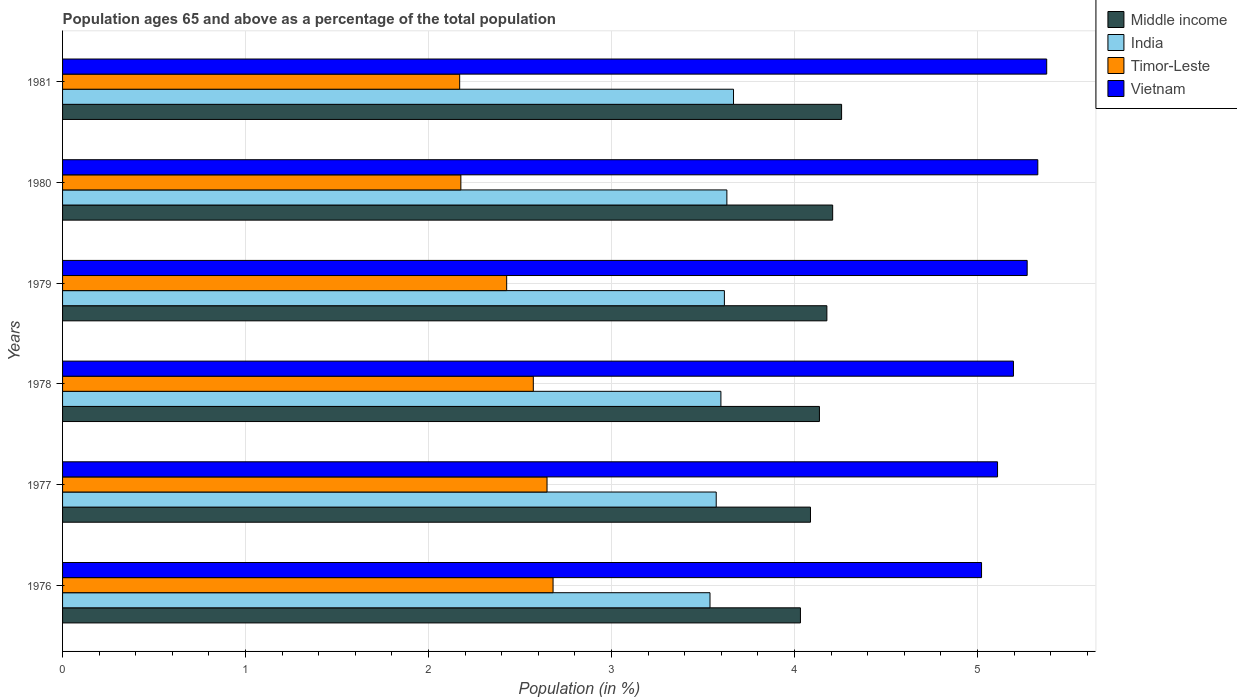How many different coloured bars are there?
Offer a terse response. 4. How many groups of bars are there?
Keep it short and to the point. 6. Are the number of bars per tick equal to the number of legend labels?
Ensure brevity in your answer.  Yes. How many bars are there on the 2nd tick from the top?
Make the answer very short. 4. What is the label of the 6th group of bars from the top?
Keep it short and to the point. 1976. In how many cases, is the number of bars for a given year not equal to the number of legend labels?
Make the answer very short. 0. What is the percentage of the population ages 65 and above in Vietnam in 1978?
Your response must be concise. 5.2. Across all years, what is the maximum percentage of the population ages 65 and above in India?
Make the answer very short. 3.67. Across all years, what is the minimum percentage of the population ages 65 and above in Vietnam?
Ensure brevity in your answer.  5.02. In which year was the percentage of the population ages 65 and above in Timor-Leste maximum?
Keep it short and to the point. 1976. In which year was the percentage of the population ages 65 and above in Middle income minimum?
Your response must be concise. 1976. What is the total percentage of the population ages 65 and above in Timor-Leste in the graph?
Give a very brief answer. 14.68. What is the difference between the percentage of the population ages 65 and above in India in 1976 and that in 1978?
Offer a very short reply. -0.06. What is the difference between the percentage of the population ages 65 and above in India in 1981 and the percentage of the population ages 65 and above in Timor-Leste in 1978?
Make the answer very short. 1.09. What is the average percentage of the population ages 65 and above in Vietnam per year?
Provide a short and direct response. 5.22. In the year 1981, what is the difference between the percentage of the population ages 65 and above in Timor-Leste and percentage of the population ages 65 and above in Vietnam?
Keep it short and to the point. -3.21. In how many years, is the percentage of the population ages 65 and above in India greater than 4.2 ?
Make the answer very short. 0. What is the ratio of the percentage of the population ages 65 and above in India in 1979 to that in 1981?
Provide a succinct answer. 0.99. What is the difference between the highest and the second highest percentage of the population ages 65 and above in India?
Make the answer very short. 0.04. What is the difference between the highest and the lowest percentage of the population ages 65 and above in India?
Offer a very short reply. 0.13. In how many years, is the percentage of the population ages 65 and above in India greater than the average percentage of the population ages 65 and above in India taken over all years?
Your answer should be very brief. 3. Is it the case that in every year, the sum of the percentage of the population ages 65 and above in Middle income and percentage of the population ages 65 and above in India is greater than the sum of percentage of the population ages 65 and above in Timor-Leste and percentage of the population ages 65 and above in Vietnam?
Give a very brief answer. No. What does the 2nd bar from the top in 1980 represents?
Provide a short and direct response. Timor-Leste. What does the 4th bar from the bottom in 1976 represents?
Give a very brief answer. Vietnam. How many bars are there?
Provide a succinct answer. 24. Are all the bars in the graph horizontal?
Keep it short and to the point. Yes. How many years are there in the graph?
Give a very brief answer. 6. Does the graph contain any zero values?
Make the answer very short. No. Where does the legend appear in the graph?
Offer a terse response. Top right. How many legend labels are there?
Provide a short and direct response. 4. How are the legend labels stacked?
Your response must be concise. Vertical. What is the title of the graph?
Your response must be concise. Population ages 65 and above as a percentage of the total population. What is the Population (in %) of Middle income in 1976?
Provide a succinct answer. 4.03. What is the Population (in %) of India in 1976?
Offer a terse response. 3.54. What is the Population (in %) in Timor-Leste in 1976?
Your response must be concise. 2.68. What is the Population (in %) of Vietnam in 1976?
Offer a very short reply. 5.02. What is the Population (in %) in Middle income in 1977?
Provide a succinct answer. 4.09. What is the Population (in %) in India in 1977?
Offer a very short reply. 3.57. What is the Population (in %) of Timor-Leste in 1977?
Keep it short and to the point. 2.65. What is the Population (in %) of Vietnam in 1977?
Provide a succinct answer. 5.11. What is the Population (in %) of Middle income in 1978?
Offer a very short reply. 4.14. What is the Population (in %) in India in 1978?
Provide a short and direct response. 3.6. What is the Population (in %) in Timor-Leste in 1978?
Give a very brief answer. 2.57. What is the Population (in %) in Vietnam in 1978?
Ensure brevity in your answer.  5.2. What is the Population (in %) in Middle income in 1979?
Offer a very short reply. 4.18. What is the Population (in %) of India in 1979?
Offer a very short reply. 3.62. What is the Population (in %) of Timor-Leste in 1979?
Ensure brevity in your answer.  2.43. What is the Population (in %) of Vietnam in 1979?
Make the answer very short. 5.27. What is the Population (in %) of Middle income in 1980?
Give a very brief answer. 4.21. What is the Population (in %) in India in 1980?
Your response must be concise. 3.63. What is the Population (in %) in Timor-Leste in 1980?
Keep it short and to the point. 2.18. What is the Population (in %) in Vietnam in 1980?
Provide a succinct answer. 5.33. What is the Population (in %) of Middle income in 1981?
Your response must be concise. 4.26. What is the Population (in %) of India in 1981?
Provide a short and direct response. 3.67. What is the Population (in %) in Timor-Leste in 1981?
Ensure brevity in your answer.  2.17. What is the Population (in %) of Vietnam in 1981?
Provide a short and direct response. 5.38. Across all years, what is the maximum Population (in %) in Middle income?
Your answer should be very brief. 4.26. Across all years, what is the maximum Population (in %) in India?
Ensure brevity in your answer.  3.67. Across all years, what is the maximum Population (in %) of Timor-Leste?
Ensure brevity in your answer.  2.68. Across all years, what is the maximum Population (in %) of Vietnam?
Offer a very short reply. 5.38. Across all years, what is the minimum Population (in %) of Middle income?
Offer a terse response. 4.03. Across all years, what is the minimum Population (in %) in India?
Provide a succinct answer. 3.54. Across all years, what is the minimum Population (in %) in Timor-Leste?
Provide a succinct answer. 2.17. Across all years, what is the minimum Population (in %) in Vietnam?
Provide a succinct answer. 5.02. What is the total Population (in %) in Middle income in the graph?
Keep it short and to the point. 24.9. What is the total Population (in %) of India in the graph?
Offer a very short reply. 21.62. What is the total Population (in %) of Timor-Leste in the graph?
Offer a terse response. 14.68. What is the total Population (in %) in Vietnam in the graph?
Offer a terse response. 31.31. What is the difference between the Population (in %) of Middle income in 1976 and that in 1977?
Your answer should be very brief. -0.05. What is the difference between the Population (in %) of India in 1976 and that in 1977?
Offer a terse response. -0.03. What is the difference between the Population (in %) of Timor-Leste in 1976 and that in 1977?
Ensure brevity in your answer.  0.03. What is the difference between the Population (in %) of Vietnam in 1976 and that in 1977?
Your answer should be very brief. -0.09. What is the difference between the Population (in %) of Middle income in 1976 and that in 1978?
Offer a terse response. -0.1. What is the difference between the Population (in %) in India in 1976 and that in 1978?
Offer a very short reply. -0.06. What is the difference between the Population (in %) in Timor-Leste in 1976 and that in 1978?
Provide a succinct answer. 0.11. What is the difference between the Population (in %) of Vietnam in 1976 and that in 1978?
Make the answer very short. -0.17. What is the difference between the Population (in %) of Middle income in 1976 and that in 1979?
Your answer should be very brief. -0.14. What is the difference between the Population (in %) in India in 1976 and that in 1979?
Your answer should be compact. -0.08. What is the difference between the Population (in %) of Timor-Leste in 1976 and that in 1979?
Your answer should be very brief. 0.25. What is the difference between the Population (in %) of Vietnam in 1976 and that in 1979?
Keep it short and to the point. -0.25. What is the difference between the Population (in %) of Middle income in 1976 and that in 1980?
Give a very brief answer. -0.18. What is the difference between the Population (in %) of India in 1976 and that in 1980?
Your response must be concise. -0.09. What is the difference between the Population (in %) of Timor-Leste in 1976 and that in 1980?
Your answer should be very brief. 0.5. What is the difference between the Population (in %) of Vietnam in 1976 and that in 1980?
Provide a succinct answer. -0.31. What is the difference between the Population (in %) of Middle income in 1976 and that in 1981?
Make the answer very short. -0.22. What is the difference between the Population (in %) in India in 1976 and that in 1981?
Give a very brief answer. -0.13. What is the difference between the Population (in %) in Timor-Leste in 1976 and that in 1981?
Offer a terse response. 0.51. What is the difference between the Population (in %) of Vietnam in 1976 and that in 1981?
Your answer should be compact. -0.36. What is the difference between the Population (in %) of Middle income in 1977 and that in 1978?
Provide a short and direct response. -0.05. What is the difference between the Population (in %) of India in 1977 and that in 1978?
Ensure brevity in your answer.  -0.03. What is the difference between the Population (in %) in Timor-Leste in 1977 and that in 1978?
Give a very brief answer. 0.07. What is the difference between the Population (in %) in Vietnam in 1977 and that in 1978?
Provide a succinct answer. -0.09. What is the difference between the Population (in %) of Middle income in 1977 and that in 1979?
Your answer should be compact. -0.09. What is the difference between the Population (in %) in India in 1977 and that in 1979?
Keep it short and to the point. -0.04. What is the difference between the Population (in %) of Timor-Leste in 1977 and that in 1979?
Make the answer very short. 0.22. What is the difference between the Population (in %) in Vietnam in 1977 and that in 1979?
Ensure brevity in your answer.  -0.16. What is the difference between the Population (in %) of Middle income in 1977 and that in 1980?
Give a very brief answer. -0.12. What is the difference between the Population (in %) of India in 1977 and that in 1980?
Offer a terse response. -0.06. What is the difference between the Population (in %) of Timor-Leste in 1977 and that in 1980?
Provide a short and direct response. 0.47. What is the difference between the Population (in %) of Vietnam in 1977 and that in 1980?
Give a very brief answer. -0.22. What is the difference between the Population (in %) of Middle income in 1977 and that in 1981?
Your response must be concise. -0.17. What is the difference between the Population (in %) of India in 1977 and that in 1981?
Keep it short and to the point. -0.09. What is the difference between the Population (in %) of Timor-Leste in 1977 and that in 1981?
Provide a succinct answer. 0.48. What is the difference between the Population (in %) in Vietnam in 1977 and that in 1981?
Keep it short and to the point. -0.27. What is the difference between the Population (in %) in Middle income in 1978 and that in 1979?
Keep it short and to the point. -0.04. What is the difference between the Population (in %) of India in 1978 and that in 1979?
Offer a terse response. -0.02. What is the difference between the Population (in %) in Timor-Leste in 1978 and that in 1979?
Make the answer very short. 0.15. What is the difference between the Population (in %) in Vietnam in 1978 and that in 1979?
Your response must be concise. -0.07. What is the difference between the Population (in %) of Middle income in 1978 and that in 1980?
Provide a succinct answer. -0.07. What is the difference between the Population (in %) in India in 1978 and that in 1980?
Give a very brief answer. -0.03. What is the difference between the Population (in %) of Timor-Leste in 1978 and that in 1980?
Ensure brevity in your answer.  0.4. What is the difference between the Population (in %) of Vietnam in 1978 and that in 1980?
Offer a very short reply. -0.13. What is the difference between the Population (in %) in Middle income in 1978 and that in 1981?
Your answer should be compact. -0.12. What is the difference between the Population (in %) of India in 1978 and that in 1981?
Your answer should be compact. -0.07. What is the difference between the Population (in %) in Timor-Leste in 1978 and that in 1981?
Your answer should be compact. 0.4. What is the difference between the Population (in %) of Vietnam in 1978 and that in 1981?
Your answer should be very brief. -0.18. What is the difference between the Population (in %) in Middle income in 1979 and that in 1980?
Provide a short and direct response. -0.03. What is the difference between the Population (in %) in India in 1979 and that in 1980?
Your response must be concise. -0.01. What is the difference between the Population (in %) in Timor-Leste in 1979 and that in 1980?
Keep it short and to the point. 0.25. What is the difference between the Population (in %) of Vietnam in 1979 and that in 1980?
Make the answer very short. -0.06. What is the difference between the Population (in %) of Middle income in 1979 and that in 1981?
Give a very brief answer. -0.08. What is the difference between the Population (in %) in India in 1979 and that in 1981?
Your response must be concise. -0.05. What is the difference between the Population (in %) in Timor-Leste in 1979 and that in 1981?
Give a very brief answer. 0.26. What is the difference between the Population (in %) in Vietnam in 1979 and that in 1981?
Your response must be concise. -0.11. What is the difference between the Population (in %) of Middle income in 1980 and that in 1981?
Provide a short and direct response. -0.05. What is the difference between the Population (in %) in India in 1980 and that in 1981?
Make the answer very short. -0.04. What is the difference between the Population (in %) in Timor-Leste in 1980 and that in 1981?
Provide a succinct answer. 0.01. What is the difference between the Population (in %) of Vietnam in 1980 and that in 1981?
Offer a terse response. -0.05. What is the difference between the Population (in %) of Middle income in 1976 and the Population (in %) of India in 1977?
Offer a very short reply. 0.46. What is the difference between the Population (in %) of Middle income in 1976 and the Population (in %) of Timor-Leste in 1977?
Provide a short and direct response. 1.39. What is the difference between the Population (in %) of Middle income in 1976 and the Population (in %) of Vietnam in 1977?
Give a very brief answer. -1.08. What is the difference between the Population (in %) of India in 1976 and the Population (in %) of Timor-Leste in 1977?
Your response must be concise. 0.89. What is the difference between the Population (in %) of India in 1976 and the Population (in %) of Vietnam in 1977?
Your answer should be very brief. -1.57. What is the difference between the Population (in %) in Timor-Leste in 1976 and the Population (in %) in Vietnam in 1977?
Ensure brevity in your answer.  -2.43. What is the difference between the Population (in %) of Middle income in 1976 and the Population (in %) of India in 1978?
Offer a very short reply. 0.43. What is the difference between the Population (in %) in Middle income in 1976 and the Population (in %) in Timor-Leste in 1978?
Your response must be concise. 1.46. What is the difference between the Population (in %) in Middle income in 1976 and the Population (in %) in Vietnam in 1978?
Your answer should be very brief. -1.16. What is the difference between the Population (in %) in India in 1976 and the Population (in %) in Timor-Leste in 1978?
Your answer should be compact. 0.97. What is the difference between the Population (in %) in India in 1976 and the Population (in %) in Vietnam in 1978?
Offer a very short reply. -1.66. What is the difference between the Population (in %) in Timor-Leste in 1976 and the Population (in %) in Vietnam in 1978?
Ensure brevity in your answer.  -2.52. What is the difference between the Population (in %) of Middle income in 1976 and the Population (in %) of India in 1979?
Your answer should be compact. 0.42. What is the difference between the Population (in %) of Middle income in 1976 and the Population (in %) of Timor-Leste in 1979?
Provide a short and direct response. 1.61. What is the difference between the Population (in %) in Middle income in 1976 and the Population (in %) in Vietnam in 1979?
Provide a succinct answer. -1.24. What is the difference between the Population (in %) of India in 1976 and the Population (in %) of Timor-Leste in 1979?
Offer a terse response. 1.11. What is the difference between the Population (in %) of India in 1976 and the Population (in %) of Vietnam in 1979?
Keep it short and to the point. -1.73. What is the difference between the Population (in %) of Timor-Leste in 1976 and the Population (in %) of Vietnam in 1979?
Your answer should be very brief. -2.59. What is the difference between the Population (in %) of Middle income in 1976 and the Population (in %) of India in 1980?
Ensure brevity in your answer.  0.4. What is the difference between the Population (in %) in Middle income in 1976 and the Population (in %) in Timor-Leste in 1980?
Offer a terse response. 1.86. What is the difference between the Population (in %) in Middle income in 1976 and the Population (in %) in Vietnam in 1980?
Your response must be concise. -1.3. What is the difference between the Population (in %) of India in 1976 and the Population (in %) of Timor-Leste in 1980?
Offer a terse response. 1.36. What is the difference between the Population (in %) in India in 1976 and the Population (in %) in Vietnam in 1980?
Offer a very short reply. -1.79. What is the difference between the Population (in %) of Timor-Leste in 1976 and the Population (in %) of Vietnam in 1980?
Your answer should be compact. -2.65. What is the difference between the Population (in %) in Middle income in 1976 and the Population (in %) in India in 1981?
Ensure brevity in your answer.  0.37. What is the difference between the Population (in %) of Middle income in 1976 and the Population (in %) of Timor-Leste in 1981?
Provide a succinct answer. 1.86. What is the difference between the Population (in %) of Middle income in 1976 and the Population (in %) of Vietnam in 1981?
Offer a terse response. -1.35. What is the difference between the Population (in %) in India in 1976 and the Population (in %) in Timor-Leste in 1981?
Make the answer very short. 1.37. What is the difference between the Population (in %) in India in 1976 and the Population (in %) in Vietnam in 1981?
Make the answer very short. -1.84. What is the difference between the Population (in %) of Timor-Leste in 1976 and the Population (in %) of Vietnam in 1981?
Provide a succinct answer. -2.7. What is the difference between the Population (in %) of Middle income in 1977 and the Population (in %) of India in 1978?
Ensure brevity in your answer.  0.49. What is the difference between the Population (in %) of Middle income in 1977 and the Population (in %) of Timor-Leste in 1978?
Ensure brevity in your answer.  1.51. What is the difference between the Population (in %) of Middle income in 1977 and the Population (in %) of Vietnam in 1978?
Give a very brief answer. -1.11. What is the difference between the Population (in %) of India in 1977 and the Population (in %) of Timor-Leste in 1978?
Make the answer very short. 1. What is the difference between the Population (in %) of India in 1977 and the Population (in %) of Vietnam in 1978?
Your response must be concise. -1.62. What is the difference between the Population (in %) of Timor-Leste in 1977 and the Population (in %) of Vietnam in 1978?
Your answer should be very brief. -2.55. What is the difference between the Population (in %) in Middle income in 1977 and the Population (in %) in India in 1979?
Offer a very short reply. 0.47. What is the difference between the Population (in %) of Middle income in 1977 and the Population (in %) of Timor-Leste in 1979?
Offer a terse response. 1.66. What is the difference between the Population (in %) of Middle income in 1977 and the Population (in %) of Vietnam in 1979?
Your response must be concise. -1.18. What is the difference between the Population (in %) in India in 1977 and the Population (in %) in Timor-Leste in 1979?
Keep it short and to the point. 1.15. What is the difference between the Population (in %) of India in 1977 and the Population (in %) of Vietnam in 1979?
Ensure brevity in your answer.  -1.7. What is the difference between the Population (in %) of Timor-Leste in 1977 and the Population (in %) of Vietnam in 1979?
Give a very brief answer. -2.62. What is the difference between the Population (in %) of Middle income in 1977 and the Population (in %) of India in 1980?
Your response must be concise. 0.46. What is the difference between the Population (in %) of Middle income in 1977 and the Population (in %) of Timor-Leste in 1980?
Your answer should be compact. 1.91. What is the difference between the Population (in %) in Middle income in 1977 and the Population (in %) in Vietnam in 1980?
Provide a succinct answer. -1.24. What is the difference between the Population (in %) in India in 1977 and the Population (in %) in Timor-Leste in 1980?
Provide a succinct answer. 1.4. What is the difference between the Population (in %) of India in 1977 and the Population (in %) of Vietnam in 1980?
Provide a succinct answer. -1.76. What is the difference between the Population (in %) in Timor-Leste in 1977 and the Population (in %) in Vietnam in 1980?
Your answer should be compact. -2.68. What is the difference between the Population (in %) in Middle income in 1977 and the Population (in %) in India in 1981?
Your answer should be compact. 0.42. What is the difference between the Population (in %) in Middle income in 1977 and the Population (in %) in Timor-Leste in 1981?
Offer a very short reply. 1.92. What is the difference between the Population (in %) of Middle income in 1977 and the Population (in %) of Vietnam in 1981?
Your answer should be very brief. -1.29. What is the difference between the Population (in %) in India in 1977 and the Population (in %) in Timor-Leste in 1981?
Your answer should be compact. 1.4. What is the difference between the Population (in %) in India in 1977 and the Population (in %) in Vietnam in 1981?
Give a very brief answer. -1.81. What is the difference between the Population (in %) of Timor-Leste in 1977 and the Population (in %) of Vietnam in 1981?
Keep it short and to the point. -2.73. What is the difference between the Population (in %) of Middle income in 1978 and the Population (in %) of India in 1979?
Keep it short and to the point. 0.52. What is the difference between the Population (in %) in Middle income in 1978 and the Population (in %) in Timor-Leste in 1979?
Offer a very short reply. 1.71. What is the difference between the Population (in %) in Middle income in 1978 and the Population (in %) in Vietnam in 1979?
Keep it short and to the point. -1.14. What is the difference between the Population (in %) of India in 1978 and the Population (in %) of Timor-Leste in 1979?
Offer a very short reply. 1.17. What is the difference between the Population (in %) of India in 1978 and the Population (in %) of Vietnam in 1979?
Your answer should be very brief. -1.67. What is the difference between the Population (in %) in Timor-Leste in 1978 and the Population (in %) in Vietnam in 1979?
Your answer should be very brief. -2.7. What is the difference between the Population (in %) in Middle income in 1978 and the Population (in %) in India in 1980?
Provide a succinct answer. 0.51. What is the difference between the Population (in %) of Middle income in 1978 and the Population (in %) of Timor-Leste in 1980?
Make the answer very short. 1.96. What is the difference between the Population (in %) of Middle income in 1978 and the Population (in %) of Vietnam in 1980?
Provide a short and direct response. -1.19. What is the difference between the Population (in %) in India in 1978 and the Population (in %) in Timor-Leste in 1980?
Give a very brief answer. 1.42. What is the difference between the Population (in %) of India in 1978 and the Population (in %) of Vietnam in 1980?
Give a very brief answer. -1.73. What is the difference between the Population (in %) in Timor-Leste in 1978 and the Population (in %) in Vietnam in 1980?
Your response must be concise. -2.76. What is the difference between the Population (in %) of Middle income in 1978 and the Population (in %) of India in 1981?
Ensure brevity in your answer.  0.47. What is the difference between the Population (in %) of Middle income in 1978 and the Population (in %) of Timor-Leste in 1981?
Keep it short and to the point. 1.97. What is the difference between the Population (in %) of Middle income in 1978 and the Population (in %) of Vietnam in 1981?
Your response must be concise. -1.24. What is the difference between the Population (in %) in India in 1978 and the Population (in %) in Timor-Leste in 1981?
Ensure brevity in your answer.  1.43. What is the difference between the Population (in %) in India in 1978 and the Population (in %) in Vietnam in 1981?
Offer a terse response. -1.78. What is the difference between the Population (in %) of Timor-Leste in 1978 and the Population (in %) of Vietnam in 1981?
Your answer should be very brief. -2.81. What is the difference between the Population (in %) of Middle income in 1979 and the Population (in %) of India in 1980?
Keep it short and to the point. 0.55. What is the difference between the Population (in %) in Middle income in 1979 and the Population (in %) in Timor-Leste in 1980?
Your response must be concise. 2. What is the difference between the Population (in %) in Middle income in 1979 and the Population (in %) in Vietnam in 1980?
Ensure brevity in your answer.  -1.15. What is the difference between the Population (in %) of India in 1979 and the Population (in %) of Timor-Leste in 1980?
Give a very brief answer. 1.44. What is the difference between the Population (in %) in India in 1979 and the Population (in %) in Vietnam in 1980?
Offer a terse response. -1.71. What is the difference between the Population (in %) of Timor-Leste in 1979 and the Population (in %) of Vietnam in 1980?
Ensure brevity in your answer.  -2.9. What is the difference between the Population (in %) of Middle income in 1979 and the Population (in %) of India in 1981?
Give a very brief answer. 0.51. What is the difference between the Population (in %) of Middle income in 1979 and the Population (in %) of Timor-Leste in 1981?
Provide a short and direct response. 2.01. What is the difference between the Population (in %) in Middle income in 1979 and the Population (in %) in Vietnam in 1981?
Keep it short and to the point. -1.2. What is the difference between the Population (in %) of India in 1979 and the Population (in %) of Timor-Leste in 1981?
Provide a succinct answer. 1.45. What is the difference between the Population (in %) in India in 1979 and the Population (in %) in Vietnam in 1981?
Provide a short and direct response. -1.76. What is the difference between the Population (in %) in Timor-Leste in 1979 and the Population (in %) in Vietnam in 1981?
Keep it short and to the point. -2.95. What is the difference between the Population (in %) in Middle income in 1980 and the Population (in %) in India in 1981?
Your response must be concise. 0.54. What is the difference between the Population (in %) in Middle income in 1980 and the Population (in %) in Timor-Leste in 1981?
Give a very brief answer. 2.04. What is the difference between the Population (in %) in Middle income in 1980 and the Population (in %) in Vietnam in 1981?
Keep it short and to the point. -1.17. What is the difference between the Population (in %) in India in 1980 and the Population (in %) in Timor-Leste in 1981?
Ensure brevity in your answer.  1.46. What is the difference between the Population (in %) in India in 1980 and the Population (in %) in Vietnam in 1981?
Provide a short and direct response. -1.75. What is the difference between the Population (in %) of Timor-Leste in 1980 and the Population (in %) of Vietnam in 1981?
Provide a short and direct response. -3.2. What is the average Population (in %) in Middle income per year?
Make the answer very short. 4.15. What is the average Population (in %) in India per year?
Give a very brief answer. 3.6. What is the average Population (in %) in Timor-Leste per year?
Give a very brief answer. 2.45. What is the average Population (in %) in Vietnam per year?
Make the answer very short. 5.22. In the year 1976, what is the difference between the Population (in %) in Middle income and Population (in %) in India?
Provide a short and direct response. 0.49. In the year 1976, what is the difference between the Population (in %) in Middle income and Population (in %) in Timor-Leste?
Keep it short and to the point. 1.35. In the year 1976, what is the difference between the Population (in %) of Middle income and Population (in %) of Vietnam?
Provide a succinct answer. -0.99. In the year 1976, what is the difference between the Population (in %) of India and Population (in %) of Timor-Leste?
Your answer should be compact. 0.86. In the year 1976, what is the difference between the Population (in %) of India and Population (in %) of Vietnam?
Your response must be concise. -1.48. In the year 1976, what is the difference between the Population (in %) of Timor-Leste and Population (in %) of Vietnam?
Your answer should be very brief. -2.34. In the year 1977, what is the difference between the Population (in %) of Middle income and Population (in %) of India?
Ensure brevity in your answer.  0.52. In the year 1977, what is the difference between the Population (in %) of Middle income and Population (in %) of Timor-Leste?
Your answer should be compact. 1.44. In the year 1977, what is the difference between the Population (in %) of Middle income and Population (in %) of Vietnam?
Your answer should be very brief. -1.02. In the year 1977, what is the difference between the Population (in %) in India and Population (in %) in Timor-Leste?
Your answer should be compact. 0.92. In the year 1977, what is the difference between the Population (in %) of India and Population (in %) of Vietnam?
Ensure brevity in your answer.  -1.54. In the year 1977, what is the difference between the Population (in %) of Timor-Leste and Population (in %) of Vietnam?
Offer a terse response. -2.46. In the year 1978, what is the difference between the Population (in %) in Middle income and Population (in %) in India?
Offer a very short reply. 0.54. In the year 1978, what is the difference between the Population (in %) in Middle income and Population (in %) in Timor-Leste?
Offer a terse response. 1.56. In the year 1978, what is the difference between the Population (in %) in Middle income and Population (in %) in Vietnam?
Offer a terse response. -1.06. In the year 1978, what is the difference between the Population (in %) in India and Population (in %) in Timor-Leste?
Ensure brevity in your answer.  1.03. In the year 1978, what is the difference between the Population (in %) in India and Population (in %) in Vietnam?
Give a very brief answer. -1.6. In the year 1978, what is the difference between the Population (in %) in Timor-Leste and Population (in %) in Vietnam?
Provide a short and direct response. -2.62. In the year 1979, what is the difference between the Population (in %) in Middle income and Population (in %) in India?
Your answer should be compact. 0.56. In the year 1979, what is the difference between the Population (in %) in Middle income and Population (in %) in Vietnam?
Provide a succinct answer. -1.09. In the year 1979, what is the difference between the Population (in %) in India and Population (in %) in Timor-Leste?
Ensure brevity in your answer.  1.19. In the year 1979, what is the difference between the Population (in %) of India and Population (in %) of Vietnam?
Provide a short and direct response. -1.65. In the year 1979, what is the difference between the Population (in %) of Timor-Leste and Population (in %) of Vietnam?
Give a very brief answer. -2.84. In the year 1980, what is the difference between the Population (in %) in Middle income and Population (in %) in India?
Provide a succinct answer. 0.58. In the year 1980, what is the difference between the Population (in %) in Middle income and Population (in %) in Timor-Leste?
Provide a succinct answer. 2.03. In the year 1980, what is the difference between the Population (in %) of Middle income and Population (in %) of Vietnam?
Your answer should be very brief. -1.12. In the year 1980, what is the difference between the Population (in %) in India and Population (in %) in Timor-Leste?
Ensure brevity in your answer.  1.45. In the year 1980, what is the difference between the Population (in %) in India and Population (in %) in Vietnam?
Offer a very short reply. -1.7. In the year 1980, what is the difference between the Population (in %) of Timor-Leste and Population (in %) of Vietnam?
Ensure brevity in your answer.  -3.15. In the year 1981, what is the difference between the Population (in %) of Middle income and Population (in %) of India?
Offer a terse response. 0.59. In the year 1981, what is the difference between the Population (in %) in Middle income and Population (in %) in Timor-Leste?
Give a very brief answer. 2.09. In the year 1981, what is the difference between the Population (in %) of Middle income and Population (in %) of Vietnam?
Offer a very short reply. -1.12. In the year 1981, what is the difference between the Population (in %) of India and Population (in %) of Timor-Leste?
Give a very brief answer. 1.5. In the year 1981, what is the difference between the Population (in %) of India and Population (in %) of Vietnam?
Your response must be concise. -1.71. In the year 1981, what is the difference between the Population (in %) in Timor-Leste and Population (in %) in Vietnam?
Offer a very short reply. -3.21. What is the ratio of the Population (in %) in Middle income in 1976 to that in 1977?
Your answer should be very brief. 0.99. What is the ratio of the Population (in %) in Timor-Leste in 1976 to that in 1977?
Ensure brevity in your answer.  1.01. What is the ratio of the Population (in %) in Vietnam in 1976 to that in 1977?
Your response must be concise. 0.98. What is the ratio of the Population (in %) in Middle income in 1976 to that in 1978?
Ensure brevity in your answer.  0.97. What is the ratio of the Population (in %) of India in 1976 to that in 1978?
Your response must be concise. 0.98. What is the ratio of the Population (in %) of Timor-Leste in 1976 to that in 1978?
Provide a succinct answer. 1.04. What is the ratio of the Population (in %) in Vietnam in 1976 to that in 1978?
Your answer should be very brief. 0.97. What is the ratio of the Population (in %) in Middle income in 1976 to that in 1979?
Ensure brevity in your answer.  0.97. What is the ratio of the Population (in %) of India in 1976 to that in 1979?
Your answer should be very brief. 0.98. What is the ratio of the Population (in %) of Timor-Leste in 1976 to that in 1979?
Provide a succinct answer. 1.1. What is the ratio of the Population (in %) in Vietnam in 1976 to that in 1979?
Your response must be concise. 0.95. What is the ratio of the Population (in %) of Middle income in 1976 to that in 1980?
Provide a succinct answer. 0.96. What is the ratio of the Population (in %) of India in 1976 to that in 1980?
Give a very brief answer. 0.97. What is the ratio of the Population (in %) of Timor-Leste in 1976 to that in 1980?
Provide a short and direct response. 1.23. What is the ratio of the Population (in %) in Vietnam in 1976 to that in 1980?
Your answer should be compact. 0.94. What is the ratio of the Population (in %) in Middle income in 1976 to that in 1981?
Keep it short and to the point. 0.95. What is the ratio of the Population (in %) of India in 1976 to that in 1981?
Provide a short and direct response. 0.96. What is the ratio of the Population (in %) of Timor-Leste in 1976 to that in 1981?
Make the answer very short. 1.24. What is the ratio of the Population (in %) of Vietnam in 1976 to that in 1981?
Provide a succinct answer. 0.93. What is the ratio of the Population (in %) in Middle income in 1977 to that in 1978?
Keep it short and to the point. 0.99. What is the ratio of the Population (in %) of India in 1977 to that in 1978?
Give a very brief answer. 0.99. What is the ratio of the Population (in %) of Timor-Leste in 1977 to that in 1978?
Your answer should be compact. 1.03. What is the ratio of the Population (in %) in Vietnam in 1977 to that in 1978?
Offer a very short reply. 0.98. What is the ratio of the Population (in %) of Middle income in 1977 to that in 1979?
Your response must be concise. 0.98. What is the ratio of the Population (in %) of India in 1977 to that in 1979?
Provide a short and direct response. 0.99. What is the ratio of the Population (in %) in Vietnam in 1977 to that in 1979?
Make the answer very short. 0.97. What is the ratio of the Population (in %) in Middle income in 1977 to that in 1980?
Your response must be concise. 0.97. What is the ratio of the Population (in %) in India in 1977 to that in 1980?
Provide a short and direct response. 0.98. What is the ratio of the Population (in %) in Timor-Leste in 1977 to that in 1980?
Keep it short and to the point. 1.22. What is the ratio of the Population (in %) in Vietnam in 1977 to that in 1980?
Make the answer very short. 0.96. What is the ratio of the Population (in %) of Middle income in 1977 to that in 1981?
Provide a short and direct response. 0.96. What is the ratio of the Population (in %) in India in 1977 to that in 1981?
Offer a very short reply. 0.97. What is the ratio of the Population (in %) in Timor-Leste in 1977 to that in 1981?
Give a very brief answer. 1.22. What is the ratio of the Population (in %) in Vietnam in 1977 to that in 1981?
Your response must be concise. 0.95. What is the ratio of the Population (in %) of Middle income in 1978 to that in 1979?
Give a very brief answer. 0.99. What is the ratio of the Population (in %) in Timor-Leste in 1978 to that in 1979?
Your answer should be very brief. 1.06. What is the ratio of the Population (in %) in Vietnam in 1978 to that in 1979?
Your response must be concise. 0.99. What is the ratio of the Population (in %) of Middle income in 1978 to that in 1980?
Your answer should be very brief. 0.98. What is the ratio of the Population (in %) of Timor-Leste in 1978 to that in 1980?
Provide a succinct answer. 1.18. What is the ratio of the Population (in %) of Vietnam in 1978 to that in 1980?
Offer a very short reply. 0.97. What is the ratio of the Population (in %) of Middle income in 1978 to that in 1981?
Your answer should be very brief. 0.97. What is the ratio of the Population (in %) of India in 1978 to that in 1981?
Ensure brevity in your answer.  0.98. What is the ratio of the Population (in %) of Timor-Leste in 1978 to that in 1981?
Ensure brevity in your answer.  1.19. What is the ratio of the Population (in %) in Vietnam in 1978 to that in 1981?
Your answer should be very brief. 0.97. What is the ratio of the Population (in %) of Middle income in 1979 to that in 1980?
Your answer should be very brief. 0.99. What is the ratio of the Population (in %) in India in 1979 to that in 1980?
Offer a terse response. 1. What is the ratio of the Population (in %) in Timor-Leste in 1979 to that in 1980?
Make the answer very short. 1.11. What is the ratio of the Population (in %) in Vietnam in 1979 to that in 1980?
Your response must be concise. 0.99. What is the ratio of the Population (in %) of Middle income in 1979 to that in 1981?
Keep it short and to the point. 0.98. What is the ratio of the Population (in %) in India in 1979 to that in 1981?
Your answer should be very brief. 0.99. What is the ratio of the Population (in %) of Timor-Leste in 1979 to that in 1981?
Give a very brief answer. 1.12. What is the ratio of the Population (in %) in Vietnam in 1979 to that in 1981?
Provide a succinct answer. 0.98. What is the ratio of the Population (in %) in Vietnam in 1980 to that in 1981?
Offer a very short reply. 0.99. What is the difference between the highest and the second highest Population (in %) in Middle income?
Your answer should be compact. 0.05. What is the difference between the highest and the second highest Population (in %) of India?
Offer a terse response. 0.04. What is the difference between the highest and the second highest Population (in %) in Timor-Leste?
Your answer should be compact. 0.03. What is the difference between the highest and the second highest Population (in %) in Vietnam?
Offer a terse response. 0.05. What is the difference between the highest and the lowest Population (in %) in Middle income?
Ensure brevity in your answer.  0.22. What is the difference between the highest and the lowest Population (in %) of India?
Your answer should be very brief. 0.13. What is the difference between the highest and the lowest Population (in %) of Timor-Leste?
Your answer should be compact. 0.51. What is the difference between the highest and the lowest Population (in %) in Vietnam?
Ensure brevity in your answer.  0.36. 